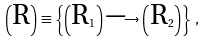<formula> <loc_0><loc_0><loc_500><loc_500>\left ( \text {R} \right ) \equiv \left \{ \left ( \text {R} _ { 1 } \right ) \longrightarrow \left ( \text {R} _ { 2 } \right ) \right \} \, ,</formula> 